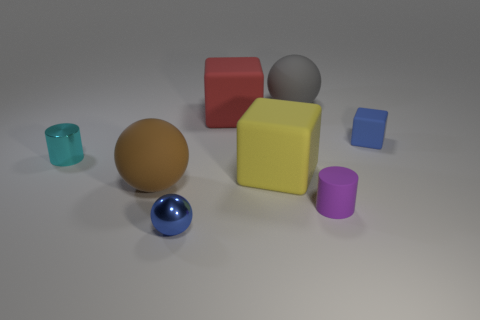There is a tiny thing that is the same color as the small ball; what is its material?
Make the answer very short. Rubber. Does the metal sphere have the same color as the small rubber block?
Ensure brevity in your answer.  Yes. What is the color of the other object that is the same shape as the purple object?
Offer a very short reply. Cyan. What number of objects are both in front of the blue matte object and to the left of the small purple rubber cylinder?
Your response must be concise. 4. Is the number of gray things that are on the left side of the purple matte object greater than the number of purple things that are behind the brown matte sphere?
Provide a short and direct response. Yes. What size is the blue rubber block?
Make the answer very short. Small. Is there a purple object of the same shape as the small cyan shiny object?
Give a very brief answer. Yes. There is a large red rubber thing; does it have the same shape as the small blue thing that is behind the large yellow cube?
Provide a succinct answer. Yes. What size is the thing that is in front of the large brown matte thing and to the left of the purple thing?
Offer a terse response. Small. What number of tiny brown shiny cylinders are there?
Keep it short and to the point. 0. 